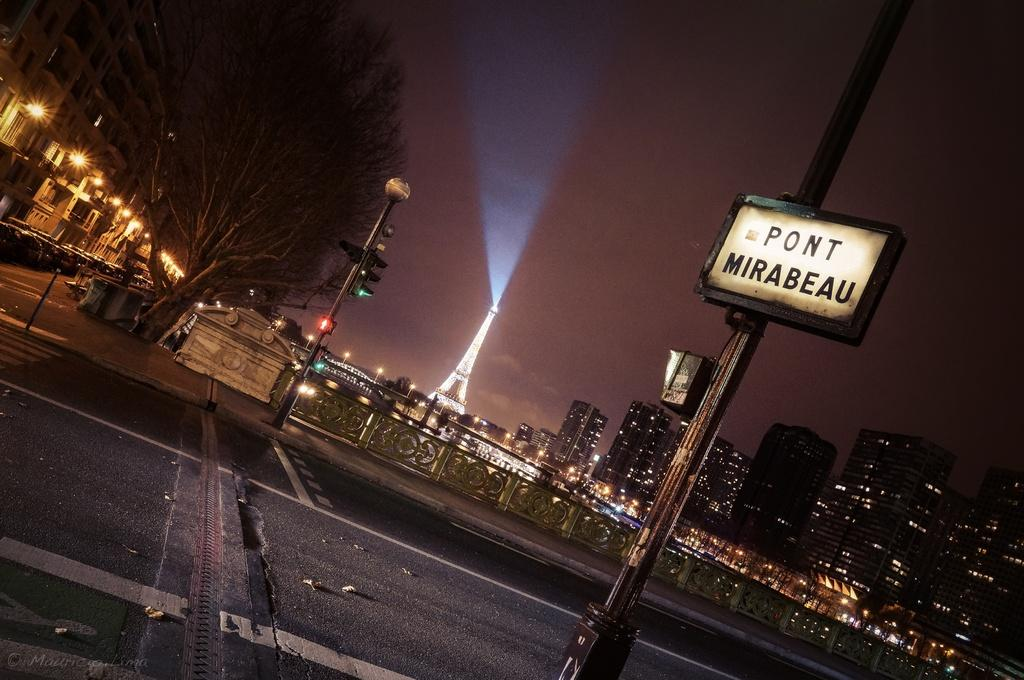What can be seen on the road in the image? There are leaves on the road in the image. What structure is on a pole in the image? There is a board on a pole in the image. What type of barrier is present in the image? There is a fence in the image. What type of illumination is present in the image? There are lights in the image. What type of plant is visible in the image? There is a tree in the image. What famous landmark is visible in the background of the image? The Eiffel Tower is visible in the background of the image. What type of man-made structures are visible in the background of the image? There are buildings in the background of the image. How many bags of popcorn are visible in the image? There are no bags of popcorn present in the image. What type of pin is holding the board on the pole in the image? There is no pin mentioned in the image, and the board is not described as being held by any specific object. 